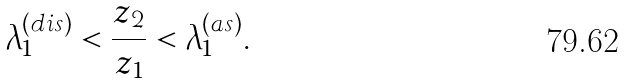Convert formula to latex. <formula><loc_0><loc_0><loc_500><loc_500>\lambda _ { 1 } ^ { ( d i s ) } < \frac { z _ { 2 } } { z _ { 1 } } < \lambda _ { 1 } ^ { ( a s ) } .</formula> 